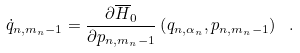Convert formula to latex. <formula><loc_0><loc_0><loc_500><loc_500>\dot { q } _ { n , m _ { n } - 1 } = \frac { \partial \overline { H } _ { 0 } } { \partial p _ { n , m _ { n } - 1 } } \left ( q _ { n , \alpha _ { n } } , p _ { n , m _ { n } - 1 } \right ) \ .</formula> 